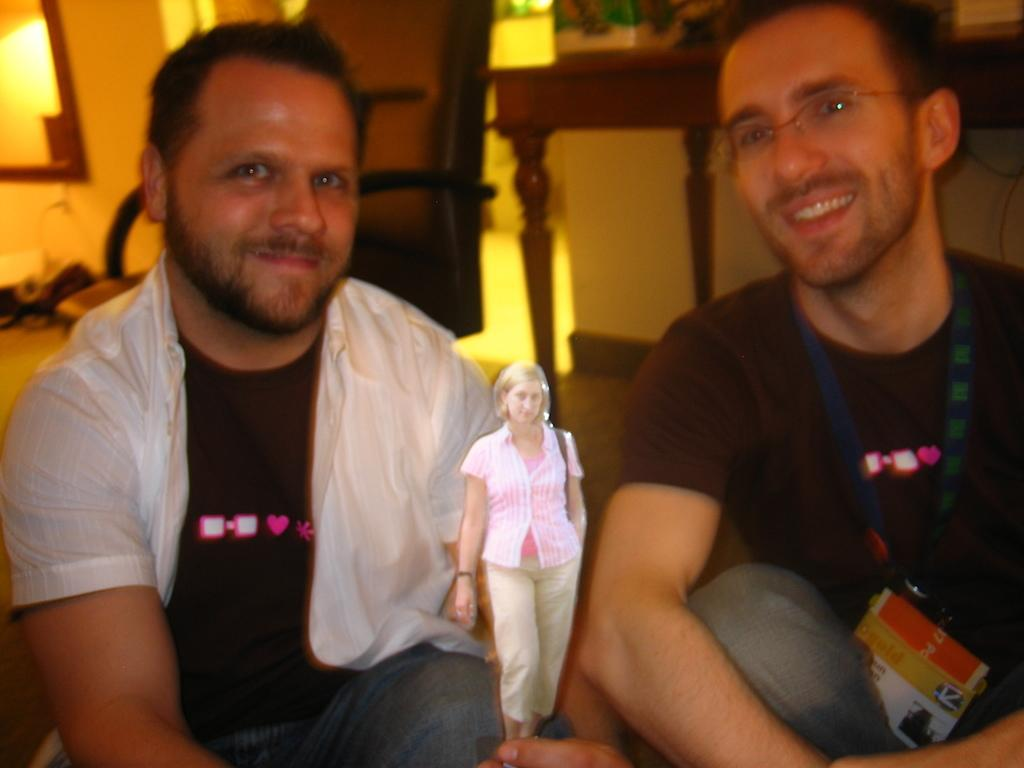What are the men in the image doing? The men in the image are sitting on the ground. What is the woman in the image doing? The woman is standing in the image. Can you describe any furniture in the background of the image? There is a chair and a table on the ground in the background of the image. How would you describe the quality of the background in the image? The background of the image is slightly blurred. How does the sofa feel to the touch in the image? There is no sofa present in the image, so it cannot be touched or felt. 